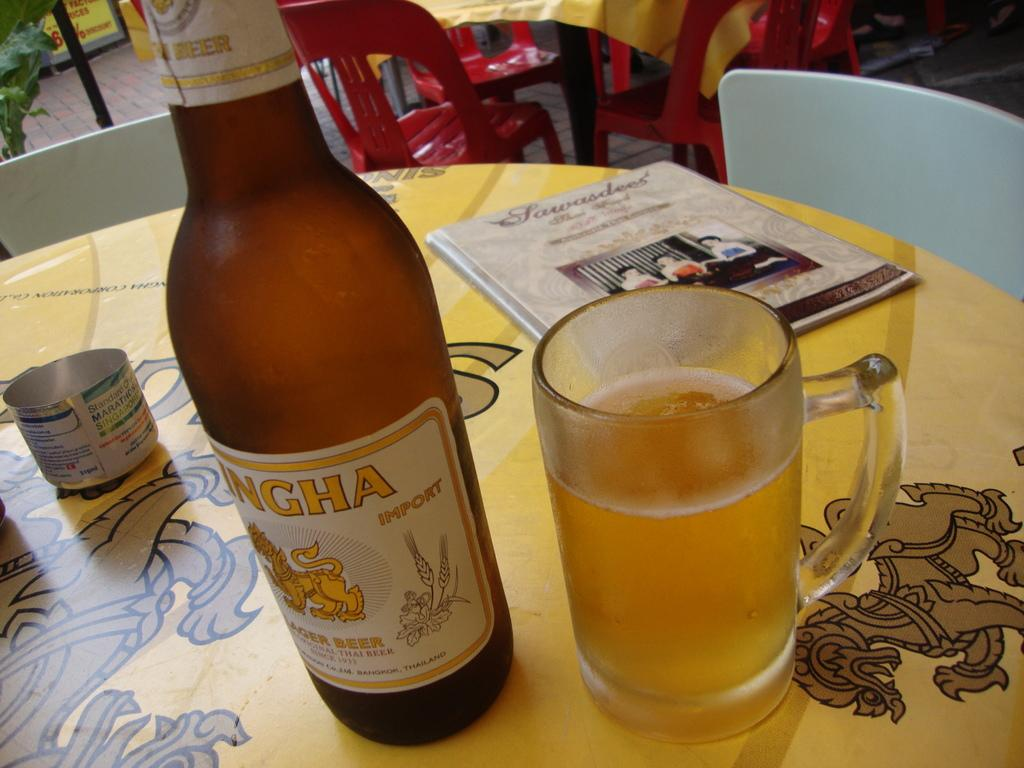<image>
Create a compact narrative representing the image presented. Singh beer bottle next to a glass of beer on top of a table. 